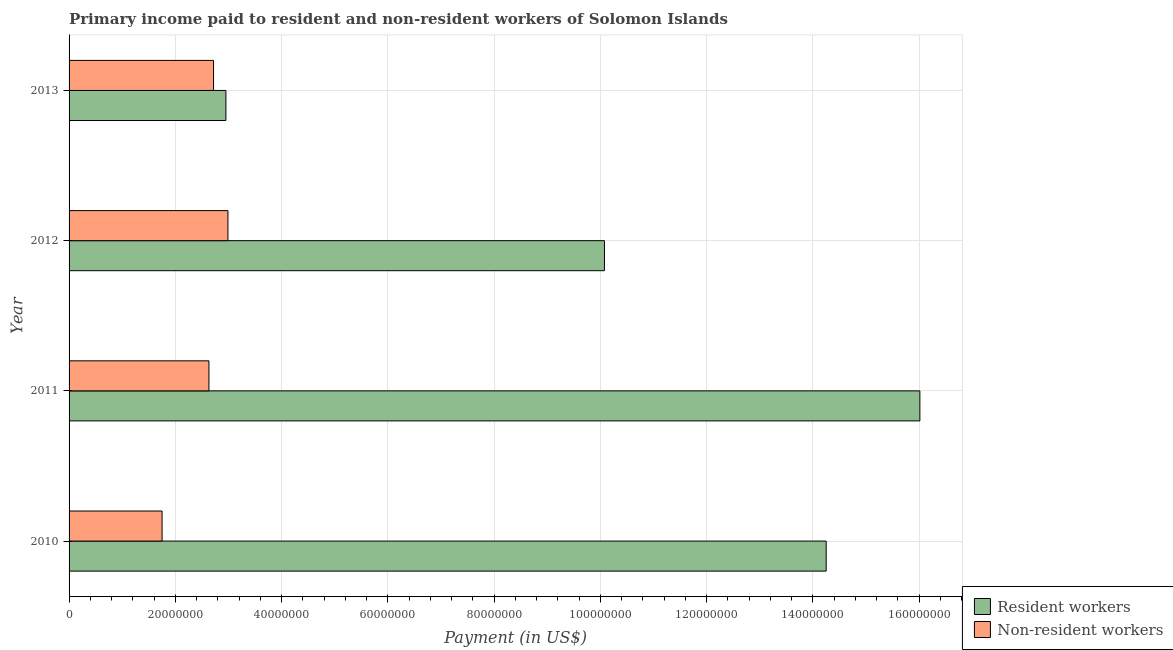How many different coloured bars are there?
Your answer should be compact. 2. Are the number of bars per tick equal to the number of legend labels?
Make the answer very short. Yes. How many bars are there on the 4th tick from the bottom?
Your answer should be very brief. 2. What is the payment made to non-resident workers in 2013?
Keep it short and to the point. 2.72e+07. Across all years, what is the maximum payment made to resident workers?
Make the answer very short. 1.60e+08. Across all years, what is the minimum payment made to non-resident workers?
Your answer should be very brief. 1.75e+07. What is the total payment made to resident workers in the graph?
Offer a very short reply. 4.33e+08. What is the difference between the payment made to non-resident workers in 2010 and that in 2013?
Your answer should be very brief. -9.68e+06. What is the difference between the payment made to non-resident workers in 2013 and the payment made to resident workers in 2012?
Your answer should be compact. -7.36e+07. What is the average payment made to resident workers per year?
Your response must be concise. 1.08e+08. In the year 2013, what is the difference between the payment made to non-resident workers and payment made to resident workers?
Provide a short and direct response. -2.33e+06. What is the ratio of the payment made to resident workers in 2010 to that in 2011?
Give a very brief answer. 0.89. Is the payment made to resident workers in 2010 less than that in 2013?
Your answer should be compact. No. What is the difference between the highest and the second highest payment made to non-resident workers?
Give a very brief answer. 2.71e+06. What is the difference between the highest and the lowest payment made to non-resident workers?
Provide a short and direct response. 1.24e+07. What does the 2nd bar from the top in 2011 represents?
Your answer should be compact. Resident workers. What does the 2nd bar from the bottom in 2011 represents?
Your answer should be very brief. Non-resident workers. Are all the bars in the graph horizontal?
Your answer should be very brief. Yes. What is the difference between two consecutive major ticks on the X-axis?
Ensure brevity in your answer.  2.00e+07. Are the values on the major ticks of X-axis written in scientific E-notation?
Your response must be concise. No. Does the graph contain grids?
Provide a short and direct response. Yes. How many legend labels are there?
Offer a terse response. 2. What is the title of the graph?
Your answer should be compact. Primary income paid to resident and non-resident workers of Solomon Islands. What is the label or title of the X-axis?
Provide a succinct answer. Payment (in US$). What is the label or title of the Y-axis?
Provide a succinct answer. Year. What is the Payment (in US$) in Resident workers in 2010?
Give a very brief answer. 1.42e+08. What is the Payment (in US$) of Non-resident workers in 2010?
Ensure brevity in your answer.  1.75e+07. What is the Payment (in US$) in Resident workers in 2011?
Your answer should be compact. 1.60e+08. What is the Payment (in US$) of Non-resident workers in 2011?
Make the answer very short. 2.63e+07. What is the Payment (in US$) of Resident workers in 2012?
Provide a succinct answer. 1.01e+08. What is the Payment (in US$) in Non-resident workers in 2012?
Your answer should be very brief. 2.99e+07. What is the Payment (in US$) in Resident workers in 2013?
Keep it short and to the point. 2.95e+07. What is the Payment (in US$) of Non-resident workers in 2013?
Your response must be concise. 2.72e+07. Across all years, what is the maximum Payment (in US$) in Resident workers?
Keep it short and to the point. 1.60e+08. Across all years, what is the maximum Payment (in US$) in Non-resident workers?
Your answer should be very brief. 2.99e+07. Across all years, what is the minimum Payment (in US$) in Resident workers?
Provide a succinct answer. 2.95e+07. Across all years, what is the minimum Payment (in US$) of Non-resident workers?
Offer a terse response. 1.75e+07. What is the total Payment (in US$) in Resident workers in the graph?
Ensure brevity in your answer.  4.33e+08. What is the total Payment (in US$) of Non-resident workers in the graph?
Make the answer very short. 1.01e+08. What is the difference between the Payment (in US$) of Resident workers in 2010 and that in 2011?
Make the answer very short. -1.76e+07. What is the difference between the Payment (in US$) in Non-resident workers in 2010 and that in 2011?
Ensure brevity in your answer.  -8.82e+06. What is the difference between the Payment (in US$) of Resident workers in 2010 and that in 2012?
Ensure brevity in your answer.  4.17e+07. What is the difference between the Payment (in US$) in Non-resident workers in 2010 and that in 2012?
Provide a succinct answer. -1.24e+07. What is the difference between the Payment (in US$) of Resident workers in 2010 and that in 2013?
Provide a short and direct response. 1.13e+08. What is the difference between the Payment (in US$) in Non-resident workers in 2010 and that in 2013?
Offer a very short reply. -9.68e+06. What is the difference between the Payment (in US$) in Resident workers in 2011 and that in 2012?
Offer a terse response. 5.94e+07. What is the difference between the Payment (in US$) in Non-resident workers in 2011 and that in 2012?
Your answer should be compact. -3.58e+06. What is the difference between the Payment (in US$) of Resident workers in 2011 and that in 2013?
Your answer should be compact. 1.31e+08. What is the difference between the Payment (in US$) in Non-resident workers in 2011 and that in 2013?
Your response must be concise. -8.66e+05. What is the difference between the Payment (in US$) of Resident workers in 2012 and that in 2013?
Your answer should be compact. 7.12e+07. What is the difference between the Payment (in US$) in Non-resident workers in 2012 and that in 2013?
Give a very brief answer. 2.71e+06. What is the difference between the Payment (in US$) in Resident workers in 2010 and the Payment (in US$) in Non-resident workers in 2011?
Give a very brief answer. 1.16e+08. What is the difference between the Payment (in US$) of Resident workers in 2010 and the Payment (in US$) of Non-resident workers in 2012?
Ensure brevity in your answer.  1.13e+08. What is the difference between the Payment (in US$) in Resident workers in 2010 and the Payment (in US$) in Non-resident workers in 2013?
Offer a very short reply. 1.15e+08. What is the difference between the Payment (in US$) of Resident workers in 2011 and the Payment (in US$) of Non-resident workers in 2012?
Make the answer very short. 1.30e+08. What is the difference between the Payment (in US$) in Resident workers in 2011 and the Payment (in US$) in Non-resident workers in 2013?
Keep it short and to the point. 1.33e+08. What is the difference between the Payment (in US$) of Resident workers in 2012 and the Payment (in US$) of Non-resident workers in 2013?
Ensure brevity in your answer.  7.36e+07. What is the average Payment (in US$) in Resident workers per year?
Make the answer very short. 1.08e+08. What is the average Payment (in US$) in Non-resident workers per year?
Provide a short and direct response. 2.52e+07. In the year 2010, what is the difference between the Payment (in US$) of Resident workers and Payment (in US$) of Non-resident workers?
Your answer should be compact. 1.25e+08. In the year 2011, what is the difference between the Payment (in US$) of Resident workers and Payment (in US$) of Non-resident workers?
Ensure brevity in your answer.  1.34e+08. In the year 2012, what is the difference between the Payment (in US$) in Resident workers and Payment (in US$) in Non-resident workers?
Offer a terse response. 7.09e+07. In the year 2013, what is the difference between the Payment (in US$) of Resident workers and Payment (in US$) of Non-resident workers?
Ensure brevity in your answer.  2.33e+06. What is the ratio of the Payment (in US$) of Resident workers in 2010 to that in 2011?
Keep it short and to the point. 0.89. What is the ratio of the Payment (in US$) in Non-resident workers in 2010 to that in 2011?
Offer a terse response. 0.67. What is the ratio of the Payment (in US$) of Resident workers in 2010 to that in 2012?
Offer a terse response. 1.41. What is the ratio of the Payment (in US$) of Non-resident workers in 2010 to that in 2012?
Ensure brevity in your answer.  0.59. What is the ratio of the Payment (in US$) in Resident workers in 2010 to that in 2013?
Offer a very short reply. 4.83. What is the ratio of the Payment (in US$) in Non-resident workers in 2010 to that in 2013?
Offer a terse response. 0.64. What is the ratio of the Payment (in US$) in Resident workers in 2011 to that in 2012?
Your answer should be compact. 1.59. What is the ratio of the Payment (in US$) of Non-resident workers in 2011 to that in 2012?
Give a very brief answer. 0.88. What is the ratio of the Payment (in US$) of Resident workers in 2011 to that in 2013?
Provide a succinct answer. 5.42. What is the ratio of the Payment (in US$) in Non-resident workers in 2011 to that in 2013?
Your response must be concise. 0.97. What is the ratio of the Payment (in US$) in Resident workers in 2012 to that in 2013?
Ensure brevity in your answer.  3.41. What is the ratio of the Payment (in US$) in Non-resident workers in 2012 to that in 2013?
Ensure brevity in your answer.  1.1. What is the difference between the highest and the second highest Payment (in US$) of Resident workers?
Keep it short and to the point. 1.76e+07. What is the difference between the highest and the second highest Payment (in US$) of Non-resident workers?
Your response must be concise. 2.71e+06. What is the difference between the highest and the lowest Payment (in US$) in Resident workers?
Your response must be concise. 1.31e+08. What is the difference between the highest and the lowest Payment (in US$) in Non-resident workers?
Keep it short and to the point. 1.24e+07. 